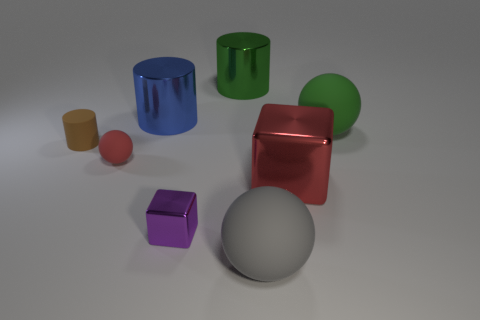There is a big metallic object left of the tiny object in front of the large shiny thing in front of the tiny ball; what shape is it?
Offer a very short reply. Cylinder. Are there more large metal things to the left of the big green cylinder than large blue blocks?
Your answer should be compact. Yes. There is a small purple thing; is its shape the same as the big shiny object that is in front of the red rubber object?
Your answer should be compact. Yes. The tiny thing that is the same color as the big cube is what shape?
Offer a very short reply. Sphere. There is a green object on the left side of the large rubber thing in front of the small brown matte object; how many large shiny cubes are behind it?
Ensure brevity in your answer.  0. What color is the rubber sphere that is the same size as the brown cylinder?
Offer a very short reply. Red. What is the size of the green object on the right side of the metallic cube that is right of the green metallic cylinder?
Give a very brief answer. Large. What size is the metal thing that is the same color as the tiny ball?
Provide a succinct answer. Large. How many other things are the same size as the purple metal thing?
Make the answer very short. 2. How many big brown rubber cylinders are there?
Offer a very short reply. 0. 